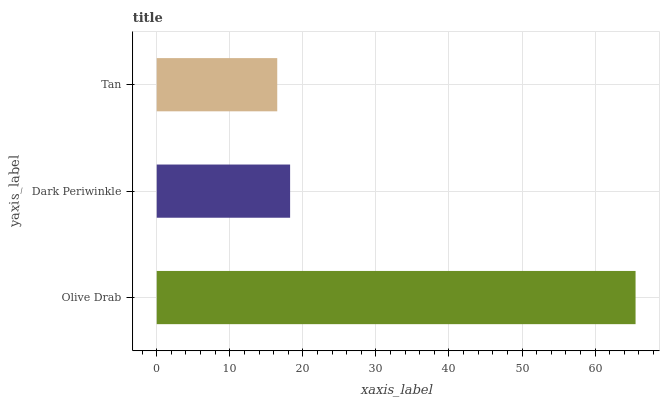Is Tan the minimum?
Answer yes or no. Yes. Is Olive Drab the maximum?
Answer yes or no. Yes. Is Dark Periwinkle the minimum?
Answer yes or no. No. Is Dark Periwinkle the maximum?
Answer yes or no. No. Is Olive Drab greater than Dark Periwinkle?
Answer yes or no. Yes. Is Dark Periwinkle less than Olive Drab?
Answer yes or no. Yes. Is Dark Periwinkle greater than Olive Drab?
Answer yes or no. No. Is Olive Drab less than Dark Periwinkle?
Answer yes or no. No. Is Dark Periwinkle the high median?
Answer yes or no. Yes. Is Dark Periwinkle the low median?
Answer yes or no. Yes. Is Tan the high median?
Answer yes or no. No. Is Olive Drab the low median?
Answer yes or no. No. 